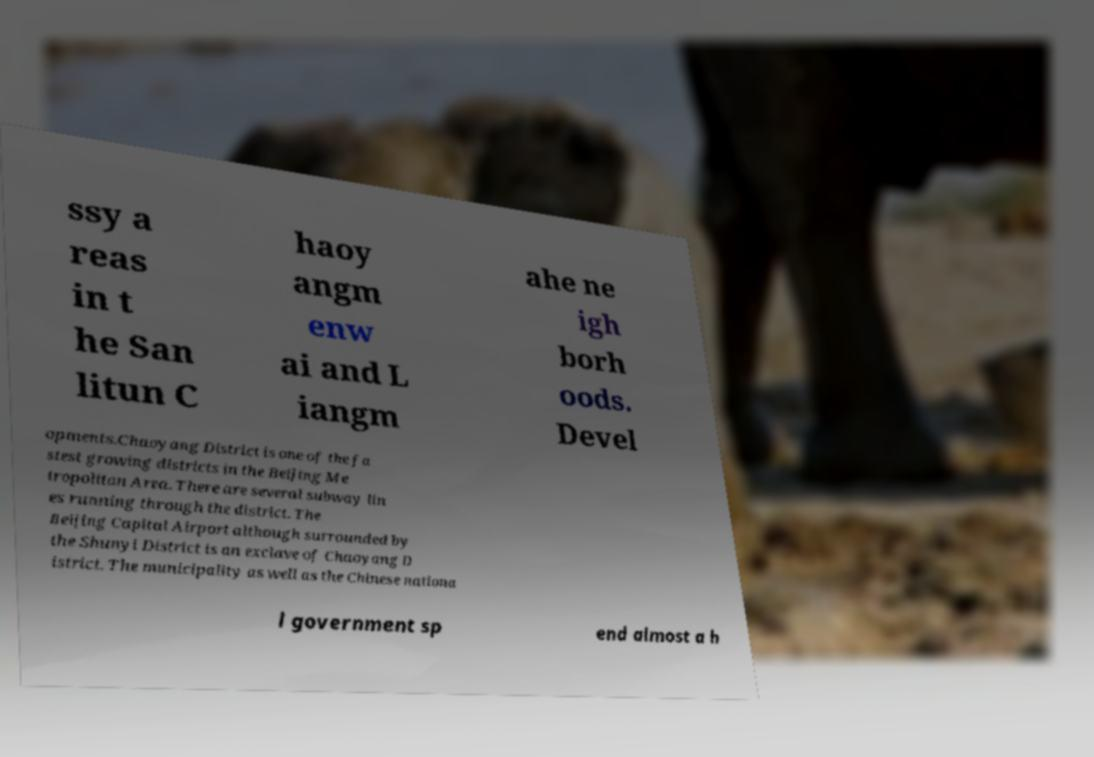Can you accurately transcribe the text from the provided image for me? ssy a reas in t he San litun C haoy angm enw ai and L iangm ahe ne igh borh oods. Devel opments.Chaoyang District is one of the fa stest growing districts in the Beijing Me tropolitan Area. There are several subway lin es running through the district. The Beijing Capital Airport although surrounded by the Shunyi District is an exclave of Chaoyang D istrict. The municipality as well as the Chinese nationa l government sp end almost a h 